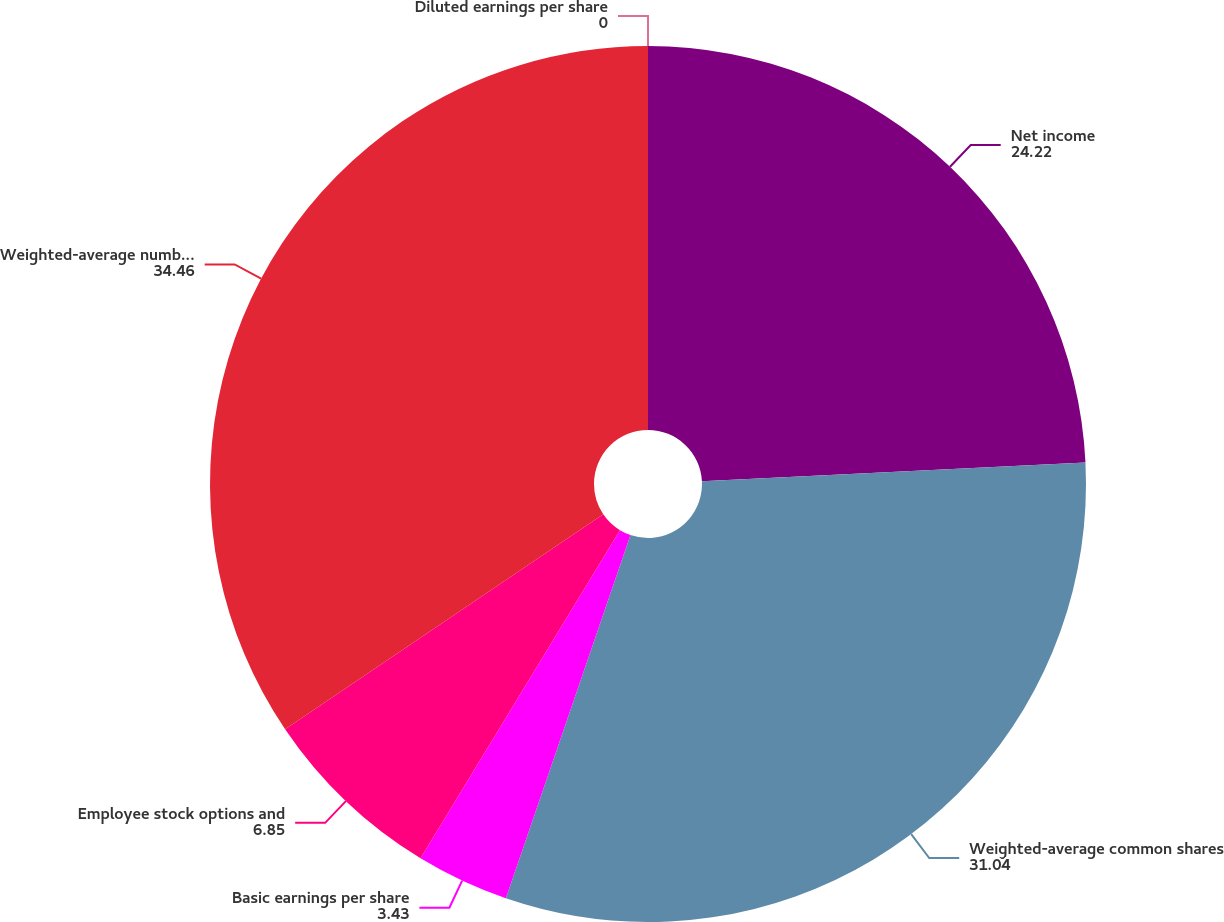Convert chart to OTSL. <chart><loc_0><loc_0><loc_500><loc_500><pie_chart><fcel>Net income<fcel>Weighted-average common shares<fcel>Basic earnings per share<fcel>Employee stock options and<fcel>Weighted-average number of<fcel>Diluted earnings per share<nl><fcel>24.22%<fcel>31.04%<fcel>3.43%<fcel>6.85%<fcel>34.46%<fcel>0.0%<nl></chart> 